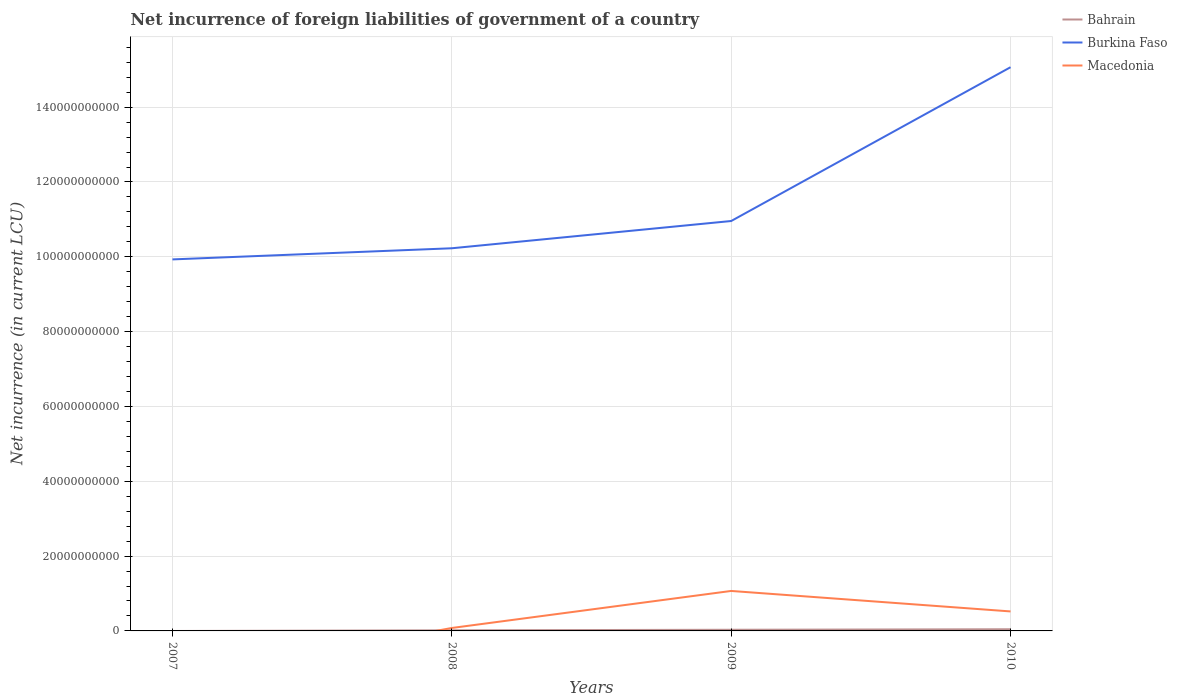Does the line corresponding to Bahrain intersect with the line corresponding to Burkina Faso?
Your answer should be compact. No. What is the total net incurrence of foreign liabilities in Bahrain in the graph?
Your answer should be compact. -1.40e+08. What is the difference between the highest and the second highest net incurrence of foreign liabilities in Bahrain?
Give a very brief answer. 4.48e+08. What is the difference between the highest and the lowest net incurrence of foreign liabilities in Burkina Faso?
Ensure brevity in your answer.  1. How many lines are there?
Offer a very short reply. 3. How many years are there in the graph?
Ensure brevity in your answer.  4. Where does the legend appear in the graph?
Your response must be concise. Top right. What is the title of the graph?
Make the answer very short. Net incurrence of foreign liabilities of government of a country. Does "Yemen, Rep." appear as one of the legend labels in the graph?
Your answer should be compact. No. What is the label or title of the Y-axis?
Keep it short and to the point. Net incurrence (in current LCU). What is the Net incurrence (in current LCU) in Bahrain in 2007?
Provide a short and direct response. 0. What is the Net incurrence (in current LCU) in Burkina Faso in 2007?
Offer a very short reply. 9.93e+1. What is the Net incurrence (in current LCU) of Macedonia in 2007?
Your response must be concise. 0. What is the Net incurrence (in current LCU) in Bahrain in 2008?
Offer a very short reply. 1.65e+08. What is the Net incurrence (in current LCU) of Burkina Faso in 2008?
Give a very brief answer. 1.02e+11. What is the Net incurrence (in current LCU) in Macedonia in 2008?
Give a very brief answer. 7.88e+08. What is the Net incurrence (in current LCU) in Bahrain in 2009?
Give a very brief answer. 3.09e+08. What is the Net incurrence (in current LCU) of Burkina Faso in 2009?
Your answer should be compact. 1.10e+11. What is the Net incurrence (in current LCU) in Macedonia in 2009?
Make the answer very short. 1.07e+1. What is the Net incurrence (in current LCU) in Bahrain in 2010?
Your answer should be very brief. 4.48e+08. What is the Net incurrence (in current LCU) of Burkina Faso in 2010?
Make the answer very short. 1.51e+11. What is the Net incurrence (in current LCU) in Macedonia in 2010?
Ensure brevity in your answer.  5.21e+09. Across all years, what is the maximum Net incurrence (in current LCU) in Bahrain?
Your answer should be very brief. 4.48e+08. Across all years, what is the maximum Net incurrence (in current LCU) of Burkina Faso?
Provide a short and direct response. 1.51e+11. Across all years, what is the maximum Net incurrence (in current LCU) of Macedonia?
Keep it short and to the point. 1.07e+1. Across all years, what is the minimum Net incurrence (in current LCU) in Bahrain?
Your answer should be compact. 0. Across all years, what is the minimum Net incurrence (in current LCU) of Burkina Faso?
Give a very brief answer. 9.93e+1. What is the total Net incurrence (in current LCU) of Bahrain in the graph?
Offer a very short reply. 9.23e+08. What is the total Net incurrence (in current LCU) in Burkina Faso in the graph?
Make the answer very short. 4.62e+11. What is the total Net incurrence (in current LCU) of Macedonia in the graph?
Offer a very short reply. 1.67e+1. What is the difference between the Net incurrence (in current LCU) in Burkina Faso in 2007 and that in 2008?
Provide a short and direct response. -2.98e+09. What is the difference between the Net incurrence (in current LCU) of Burkina Faso in 2007 and that in 2009?
Ensure brevity in your answer.  -1.03e+1. What is the difference between the Net incurrence (in current LCU) of Burkina Faso in 2007 and that in 2010?
Offer a terse response. -5.14e+1. What is the difference between the Net incurrence (in current LCU) of Bahrain in 2008 and that in 2009?
Provide a short and direct response. -1.43e+08. What is the difference between the Net incurrence (in current LCU) of Burkina Faso in 2008 and that in 2009?
Your answer should be very brief. -7.28e+09. What is the difference between the Net incurrence (in current LCU) of Macedonia in 2008 and that in 2009?
Keep it short and to the point. -9.90e+09. What is the difference between the Net incurrence (in current LCU) of Bahrain in 2008 and that in 2010?
Offer a terse response. -2.83e+08. What is the difference between the Net incurrence (in current LCU) in Burkina Faso in 2008 and that in 2010?
Offer a terse response. -4.84e+1. What is the difference between the Net incurrence (in current LCU) in Macedonia in 2008 and that in 2010?
Keep it short and to the point. -4.42e+09. What is the difference between the Net incurrence (in current LCU) in Bahrain in 2009 and that in 2010?
Provide a short and direct response. -1.40e+08. What is the difference between the Net incurrence (in current LCU) of Burkina Faso in 2009 and that in 2010?
Make the answer very short. -4.11e+1. What is the difference between the Net incurrence (in current LCU) in Macedonia in 2009 and that in 2010?
Offer a very short reply. 5.47e+09. What is the difference between the Net incurrence (in current LCU) of Burkina Faso in 2007 and the Net incurrence (in current LCU) of Macedonia in 2008?
Your answer should be compact. 9.85e+1. What is the difference between the Net incurrence (in current LCU) of Burkina Faso in 2007 and the Net incurrence (in current LCU) of Macedonia in 2009?
Your answer should be very brief. 8.86e+1. What is the difference between the Net incurrence (in current LCU) of Burkina Faso in 2007 and the Net incurrence (in current LCU) of Macedonia in 2010?
Keep it short and to the point. 9.41e+1. What is the difference between the Net incurrence (in current LCU) of Bahrain in 2008 and the Net incurrence (in current LCU) of Burkina Faso in 2009?
Offer a very short reply. -1.09e+11. What is the difference between the Net incurrence (in current LCU) in Bahrain in 2008 and the Net incurrence (in current LCU) in Macedonia in 2009?
Make the answer very short. -1.05e+1. What is the difference between the Net incurrence (in current LCU) in Burkina Faso in 2008 and the Net incurrence (in current LCU) in Macedonia in 2009?
Make the answer very short. 9.16e+1. What is the difference between the Net incurrence (in current LCU) of Bahrain in 2008 and the Net incurrence (in current LCU) of Burkina Faso in 2010?
Your response must be concise. -1.51e+11. What is the difference between the Net incurrence (in current LCU) in Bahrain in 2008 and the Net incurrence (in current LCU) in Macedonia in 2010?
Ensure brevity in your answer.  -5.04e+09. What is the difference between the Net incurrence (in current LCU) of Burkina Faso in 2008 and the Net incurrence (in current LCU) of Macedonia in 2010?
Ensure brevity in your answer.  9.71e+1. What is the difference between the Net incurrence (in current LCU) in Bahrain in 2009 and the Net incurrence (in current LCU) in Burkina Faso in 2010?
Offer a very short reply. -1.50e+11. What is the difference between the Net incurrence (in current LCU) in Bahrain in 2009 and the Net incurrence (in current LCU) in Macedonia in 2010?
Keep it short and to the point. -4.90e+09. What is the difference between the Net incurrence (in current LCU) in Burkina Faso in 2009 and the Net incurrence (in current LCU) in Macedonia in 2010?
Offer a terse response. 1.04e+11. What is the average Net incurrence (in current LCU) in Bahrain per year?
Offer a terse response. 2.31e+08. What is the average Net incurrence (in current LCU) of Burkina Faso per year?
Provide a succinct answer. 1.15e+11. What is the average Net incurrence (in current LCU) of Macedonia per year?
Make the answer very short. 4.17e+09. In the year 2008, what is the difference between the Net incurrence (in current LCU) in Bahrain and Net incurrence (in current LCU) in Burkina Faso?
Give a very brief answer. -1.02e+11. In the year 2008, what is the difference between the Net incurrence (in current LCU) in Bahrain and Net incurrence (in current LCU) in Macedonia?
Your answer should be compact. -6.23e+08. In the year 2008, what is the difference between the Net incurrence (in current LCU) in Burkina Faso and Net incurrence (in current LCU) in Macedonia?
Your answer should be very brief. 1.01e+11. In the year 2009, what is the difference between the Net incurrence (in current LCU) of Bahrain and Net incurrence (in current LCU) of Burkina Faso?
Your response must be concise. -1.09e+11. In the year 2009, what is the difference between the Net incurrence (in current LCU) of Bahrain and Net incurrence (in current LCU) of Macedonia?
Ensure brevity in your answer.  -1.04e+1. In the year 2009, what is the difference between the Net incurrence (in current LCU) of Burkina Faso and Net incurrence (in current LCU) of Macedonia?
Provide a succinct answer. 9.89e+1. In the year 2010, what is the difference between the Net incurrence (in current LCU) in Bahrain and Net incurrence (in current LCU) in Burkina Faso?
Provide a short and direct response. -1.50e+11. In the year 2010, what is the difference between the Net incurrence (in current LCU) in Bahrain and Net incurrence (in current LCU) in Macedonia?
Keep it short and to the point. -4.76e+09. In the year 2010, what is the difference between the Net incurrence (in current LCU) in Burkina Faso and Net incurrence (in current LCU) in Macedonia?
Your answer should be compact. 1.45e+11. What is the ratio of the Net incurrence (in current LCU) in Burkina Faso in 2007 to that in 2008?
Provide a succinct answer. 0.97. What is the ratio of the Net incurrence (in current LCU) of Burkina Faso in 2007 to that in 2009?
Ensure brevity in your answer.  0.91. What is the ratio of the Net incurrence (in current LCU) in Burkina Faso in 2007 to that in 2010?
Give a very brief answer. 0.66. What is the ratio of the Net incurrence (in current LCU) of Bahrain in 2008 to that in 2009?
Provide a short and direct response. 0.54. What is the ratio of the Net incurrence (in current LCU) in Burkina Faso in 2008 to that in 2009?
Your answer should be very brief. 0.93. What is the ratio of the Net incurrence (in current LCU) in Macedonia in 2008 to that in 2009?
Provide a succinct answer. 0.07. What is the ratio of the Net incurrence (in current LCU) of Bahrain in 2008 to that in 2010?
Provide a succinct answer. 0.37. What is the ratio of the Net incurrence (in current LCU) in Burkina Faso in 2008 to that in 2010?
Provide a short and direct response. 0.68. What is the ratio of the Net incurrence (in current LCU) in Macedonia in 2008 to that in 2010?
Your answer should be compact. 0.15. What is the ratio of the Net incurrence (in current LCU) in Bahrain in 2009 to that in 2010?
Make the answer very short. 0.69. What is the ratio of the Net incurrence (in current LCU) in Burkina Faso in 2009 to that in 2010?
Provide a short and direct response. 0.73. What is the ratio of the Net incurrence (in current LCU) of Macedonia in 2009 to that in 2010?
Offer a terse response. 2.05. What is the difference between the highest and the second highest Net incurrence (in current LCU) of Bahrain?
Offer a very short reply. 1.40e+08. What is the difference between the highest and the second highest Net incurrence (in current LCU) of Burkina Faso?
Your answer should be compact. 4.11e+1. What is the difference between the highest and the second highest Net incurrence (in current LCU) in Macedonia?
Make the answer very short. 5.47e+09. What is the difference between the highest and the lowest Net incurrence (in current LCU) of Bahrain?
Provide a succinct answer. 4.48e+08. What is the difference between the highest and the lowest Net incurrence (in current LCU) of Burkina Faso?
Your response must be concise. 5.14e+1. What is the difference between the highest and the lowest Net incurrence (in current LCU) in Macedonia?
Provide a short and direct response. 1.07e+1. 